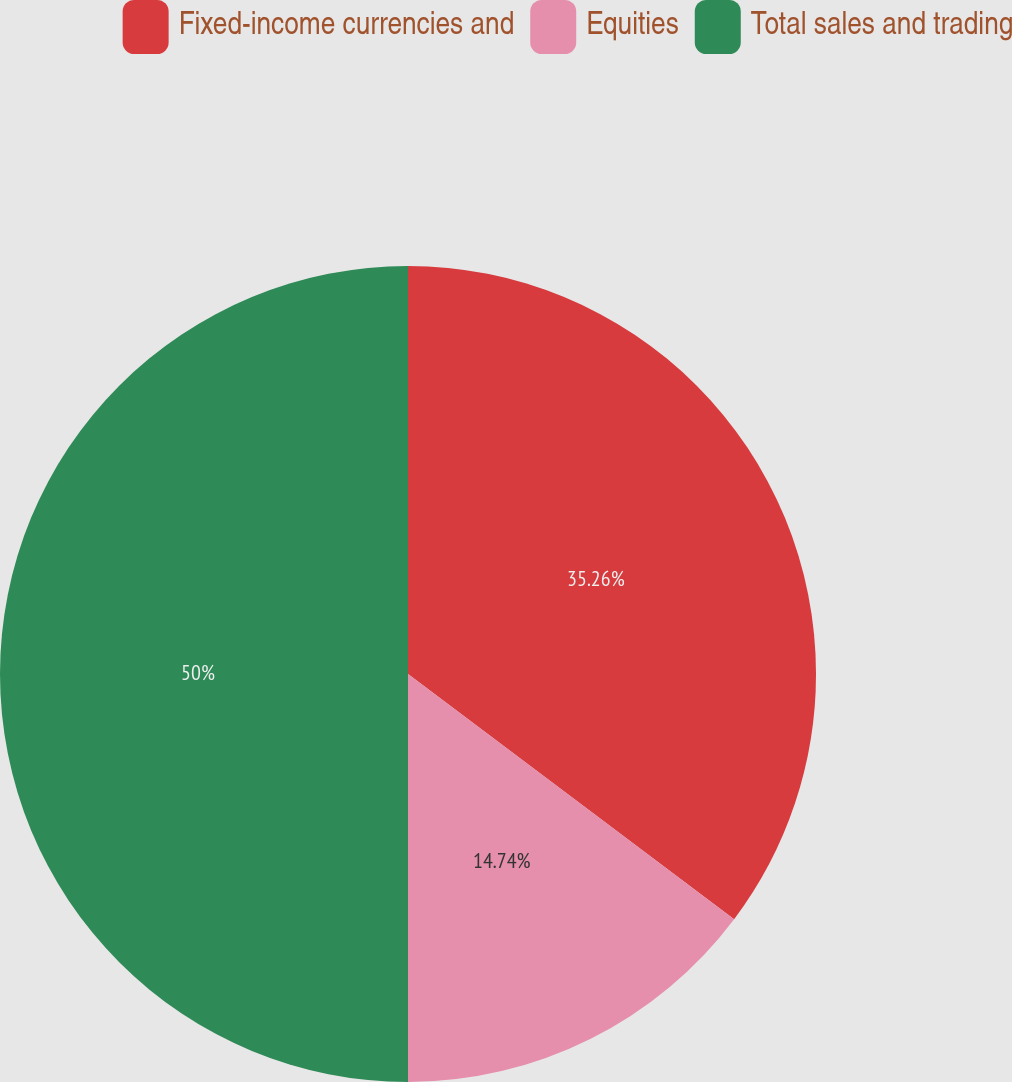<chart> <loc_0><loc_0><loc_500><loc_500><pie_chart><fcel>Fixed-income currencies and<fcel>Equities<fcel>Total sales and trading<nl><fcel>35.26%<fcel>14.74%<fcel>50.0%<nl></chart> 